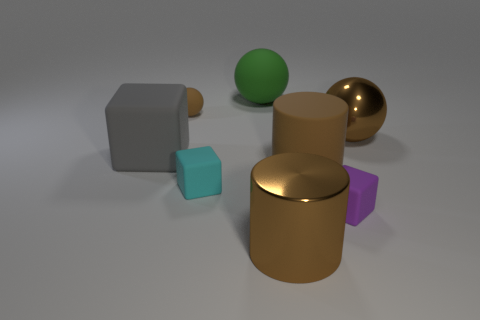There is a big object left of the small object that is behind the small cyan rubber cube that is behind the tiny purple rubber cube; what is its material?
Ensure brevity in your answer.  Rubber. There is a matte thing that is the same color as the tiny sphere; what size is it?
Your answer should be very brief. Large. What is the large gray cube made of?
Ensure brevity in your answer.  Rubber. Is the small cyan thing made of the same material as the brown cylinder in front of the purple rubber cube?
Offer a very short reply. No. The small matte object behind the brown rubber object on the right side of the tiny sphere is what color?
Give a very brief answer. Brown. There is a sphere that is right of the tiny brown rubber object and behind the big brown metal ball; what size is it?
Provide a short and direct response. Large. What number of other objects are there of the same shape as the big green rubber thing?
Your response must be concise. 2. There is a gray rubber object; is it the same shape as the tiny thing right of the big matte ball?
Provide a short and direct response. Yes. What number of large gray blocks are to the right of the purple thing?
Keep it short and to the point. 0. Is there anything else that has the same material as the green thing?
Your response must be concise. Yes. 